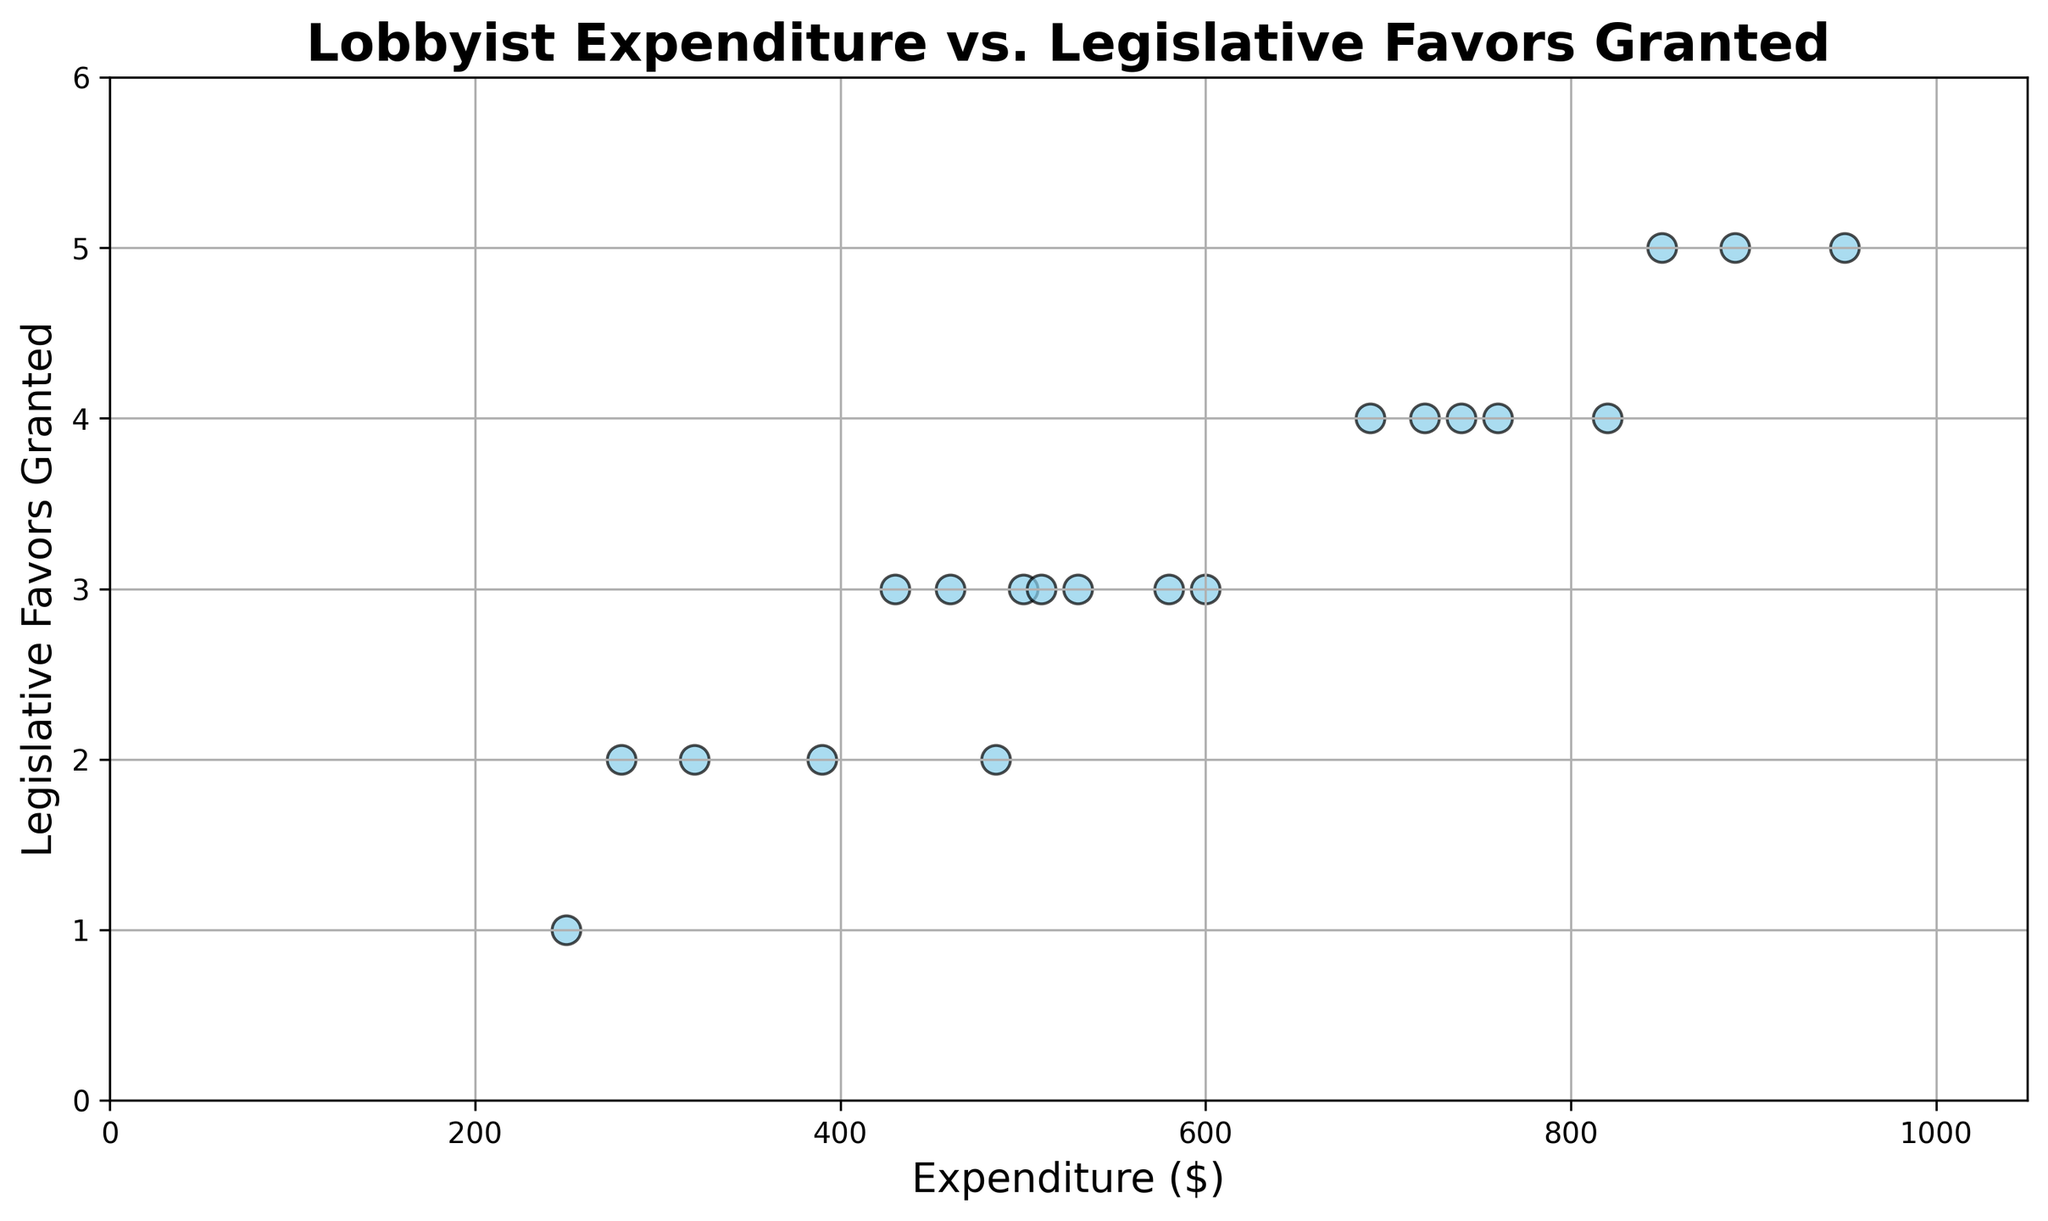Which expenditure value has the highest number of legislative favors granted? Look for the highest y-value, which is 5 (Legislative Favors), and identify the corresponding x-values (Expenditure). The expenditures with 5 legislative favors are 890, 950, and 850.
Answer: 890, 950, 850 How many data points indicate 4 legislative favors granted? Count the number of scatter plot points where the y-value (Legislative Favors) is 4. From the plot, we observe 5 points with Legislative Favors equal to 4.
Answer: 5 What is the expenditure difference between the maximum and minimum values? Identify the max and min expenditure values: max is 950 and min is 250. The difference is 950 - 250 = 700.
Answer: 700 How does the expenditure distribution look in terms of the lower and upper 25th percentile? To determine this, observe the spread of expenditure data values. The lower 25th percentile (Q1) value is around 250. The upper 25th percentile (Q3) value is around 820. This can be gleaned from noting the distribution in the scatter plot.
Answer: Q1: 250, Q3: 820 Which data point has the lowest number of legislative favors granted? Identify the smallest y-value, which is 1 (Legislative Favors). The corresponding x-value (Expenditure) for this data point is 250.
Answer: 250 